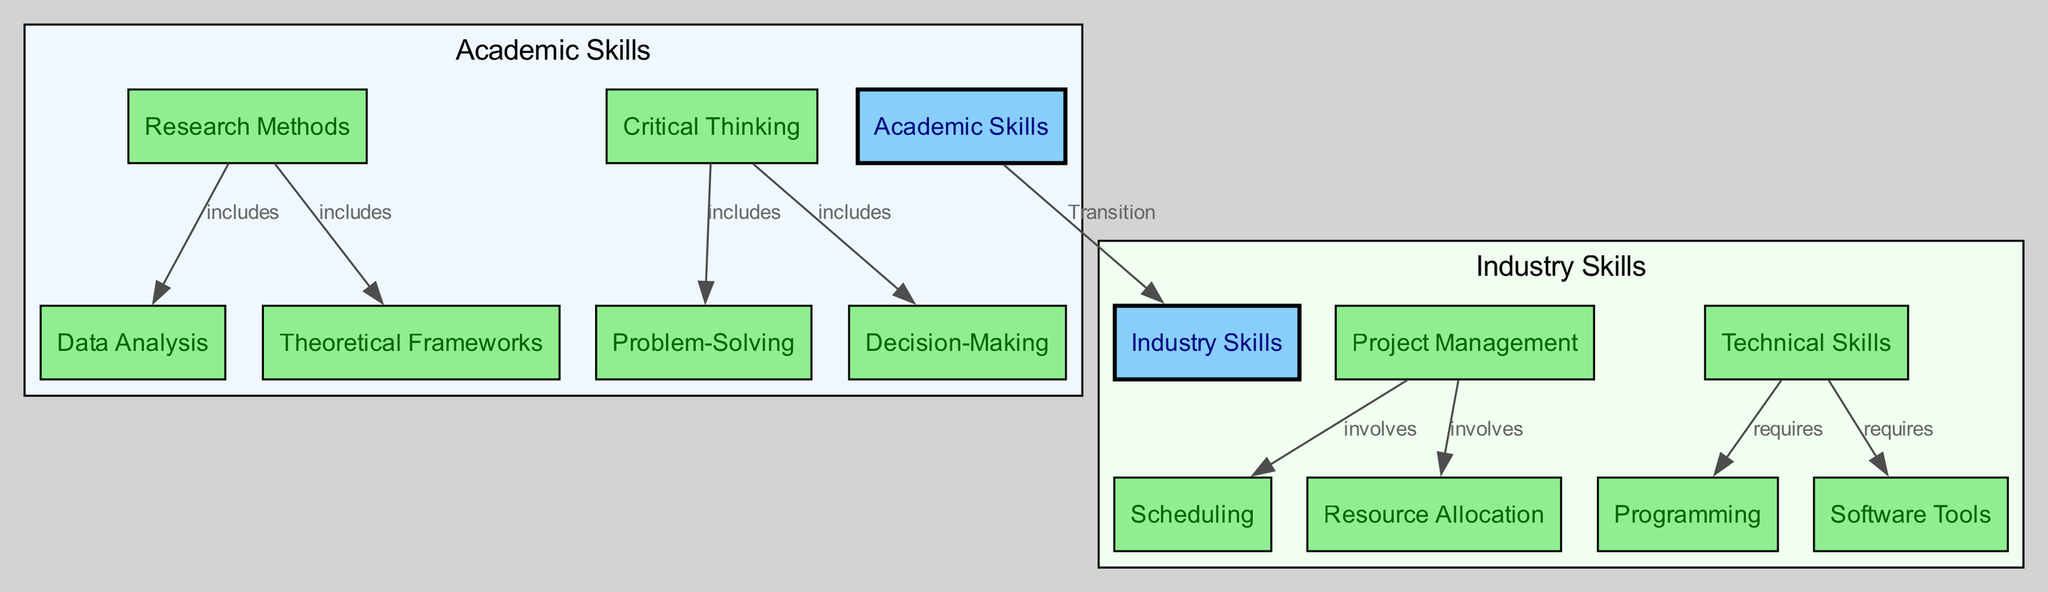What are the two main topics depicted in the diagram? The diagram directly represents two main topics labeled as "Academic Skills" and "Industry Skills." They serve as the central nodes from which sub-topics branch out.
Answer: Academic Skills and Industry Skills Which node is a sub-topic under "Research Methods"? One can directly observe from the diagram that both "Data Analysis" and "Theoretical Frameworks" are sub-topics derived from the "Research Methods" node.
Answer: Data Analysis, Theoretical Frameworks What type of relationship exists between "Critical Thinking" and "Problem-Solving"? By examining the edge that connects these two nodes, it is evident that "Critical Thinking" includes "Problem-Solving," indicating a hierarchical relationship where one encompasses the other.
Answer: includes How many sub-topics are listed under "Technical Skills"? The diagram shows "Programming" and "Software Tools" as sub-topics that branch off from the "Technical Skills" main topic. Counting these, we find there are two sub-topics.
Answer: 2 What is one of the skills involved in "Project Management"? Looking at the sub-topics under "Project Management," it is clear that both "Scheduling" and "Resource Allocation" are identified as skills that are involved in effectively managing projects.
Answer: Scheduling or Resource Allocation Which academic skill transitions to industry skills? The diagram explicitly depicts a transition from "Academic Skills" to "Industry Skills," indicating that skills from the academic field can be applied or adapted within the industry context.
Answer: Transition What are the two main facets of critical thinking shown in the diagram? Within the critical thinking node, we can see that "Problem-Solving" and "Decision-Making" are highlighted as its key facets, connecting the general concept of critical thinking to specific applications.
Answer: Problem-Solving and Decision-Making What unique label describes the type of connection from "Research Methods" to "Data Analysis"? The connection from "Research Methods" to "Data Analysis" is designated by the label "includes," indicating that data analysis is a component or part of research methods in this context.
Answer: includes How are the nodes categorized in the diagram? The diagram categorizes nodes into two primary clusters based on their relevance: "Academic Skills," which focuses on educational competencies, and "Industry Skills," which concentrates on practical applications in the workforce.
Answer: Academic Skills, Industry Skills 